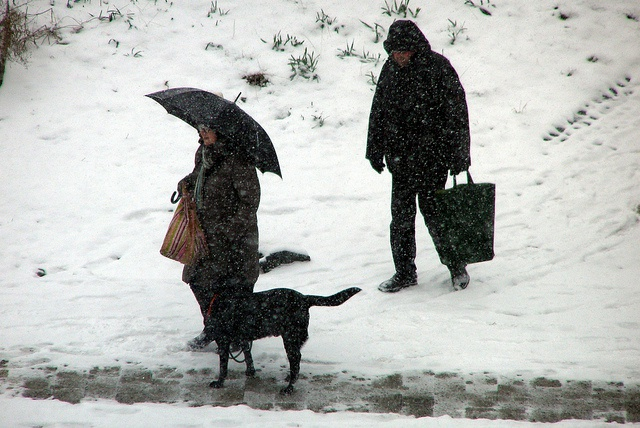Describe the objects in this image and their specific colors. I can see people in gray, black, white, and darkgreen tones, people in gray, black, and maroon tones, dog in gray, black, teal, and maroon tones, handbag in gray, black, darkgreen, and teal tones, and umbrella in gray, black, and teal tones in this image. 